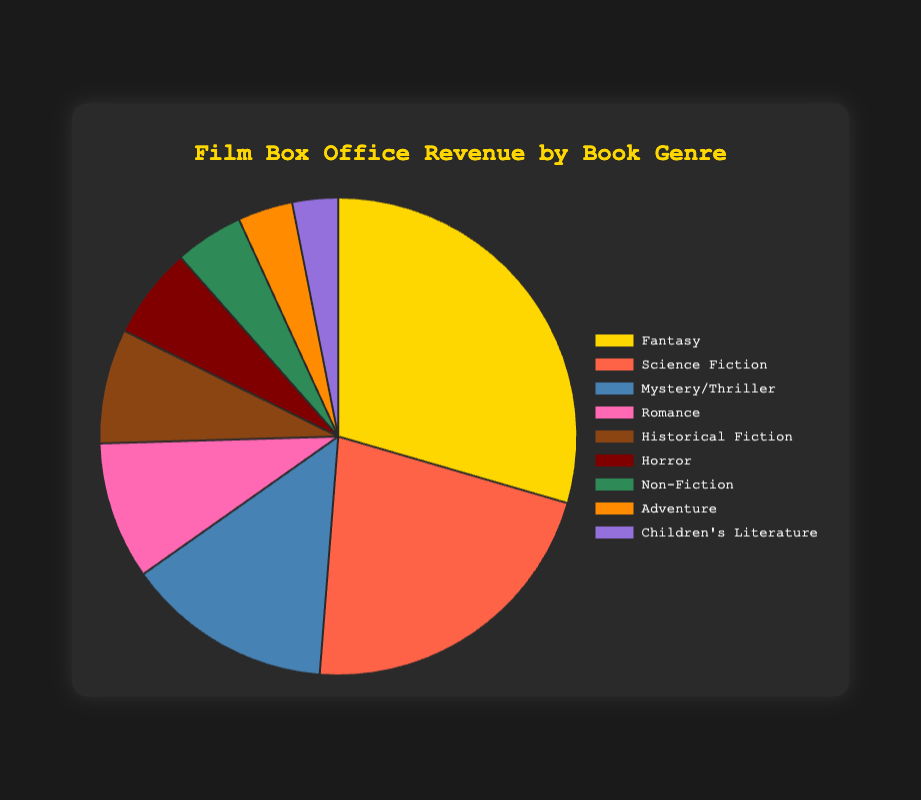What's the total box office revenue from Fantasy and Science Fiction genres? First, find the box office revenue for Fantasy which is $9.5 billion. Then, find the box office revenue for Science Fiction which is $7 billion. Add these two numbers: $9.5 billion + $7 billion = $16.5 billion.
Answer: $16.5 billion Which genre has the highest box office revenue? Compare the box office revenues of all genres. Fantasy has the highest revenue with $9.5 billion.
Answer: Fantasy Which genre has the lowest box office revenue and what is it? Compare the box office revenues of all genres. Children's Literature has the lowest revenue with $1 billion.
Answer: Children's Literature, $1 billion What is the difference in box office revenue between Mystery/Thriller and Romance genres? Find the box office revenue for Mystery/Thriller which is $4.5 billion, and for Romance which is $3 billion. Subtract the latter from the former: $4.5 billion - $3 billion = $1.5 billion.
Answer: $1.5 billion Which genre has a box office revenue that is slightly higher than Non-Fiction? Find the box office revenue for Non-Fiction which is $1.5 billion. The box office revenue for Adventure is $1.2 billion and for Children's Literature is $1 billion; neither is higher. The next lowest is Horror at $2 billion.
Answer: Horror What’s the average box office revenue of all genres? Sum all the box office revenues: $9.5 billion + $7 billion + $4.5 billion + $3 billion + $2.5 billion + $2 billion + $1.5 billion + $1.2 billion + $1 billion = $31.2 billion. Divide this sum by the number of genres, which is 9: $31.2 billion / 9 ≈ $3.47 billion.
Answer: $3.47 billion Which genre has the second highest box office revenue, and what is the revenue? Compare all box office revenues. The highest is Fantasy with $9.5 billion, and the second highest is Science Fiction with $7 billion.
Answer: Science Fiction, $7 billion How does the box office revenue from Romance compare to that of Historical Fiction? Find the box office revenues: Romance is $3 billion, and Historical Fiction is $2.5 billion. Romance has $0.5 billion more than Historical Fiction.
Answer: Romance is higher by $0.5 billion What percentage of the total box office revenue is made up by the Adventure genre? Find the box office revenue for Adventure which is $1.2 billion and the total box office revenue which is $31.2 billion. Calculate the percentage: ($1.2 billion / $31.2 billion) * 100 ≈ 3.85%.
Answer: 3.85% What is the combined box office revenue of all genres except for Fantasy? Subtract Fantasy's box office revenue from the total box office revenue: $31.2 billion - $9.5 billion = $21.7 billion.
Answer: $21.7 billion 